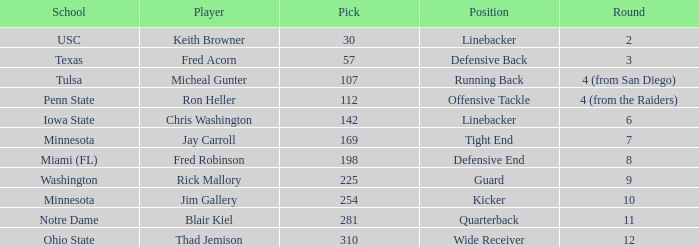What is the highest pick from Washington? 225.0. 